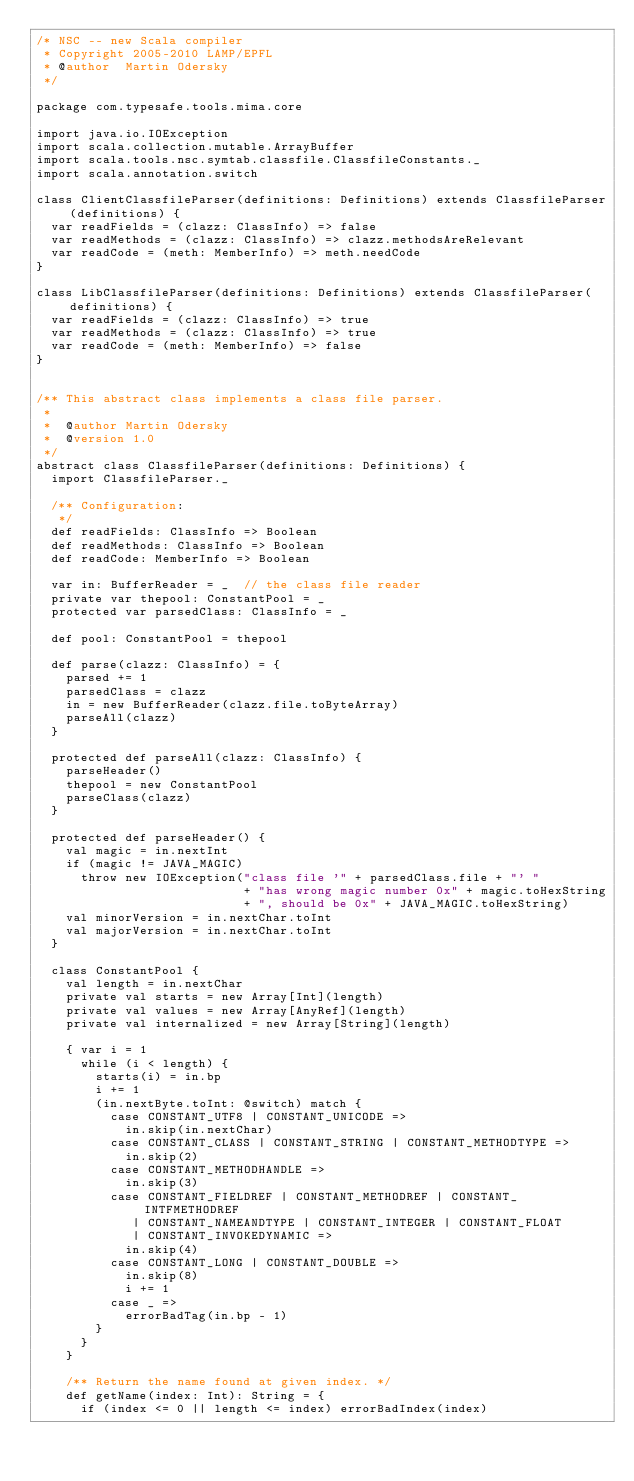<code> <loc_0><loc_0><loc_500><loc_500><_Scala_>/* NSC -- new Scala compiler
 * Copyright 2005-2010 LAMP/EPFL
 * @author  Martin Odersky
 */

package com.typesafe.tools.mima.core

import java.io.IOException
import scala.collection.mutable.ArrayBuffer
import scala.tools.nsc.symtab.classfile.ClassfileConstants._
import scala.annotation.switch

class ClientClassfileParser(definitions: Definitions) extends ClassfileParser(definitions) {
  var readFields = (clazz: ClassInfo) => false
  var readMethods = (clazz: ClassInfo) => clazz.methodsAreRelevant
  var readCode = (meth: MemberInfo) => meth.needCode
}

class LibClassfileParser(definitions: Definitions) extends ClassfileParser(definitions) {
  var readFields = (clazz: ClassInfo) => true
  var readMethods = (clazz: ClassInfo) => true
  var readCode = (meth: MemberInfo) => false
}


/** This abstract class implements a class file parser.
 *
 *  @author Martin Odersky
 *  @version 1.0
 */
abstract class ClassfileParser(definitions: Definitions) {
  import ClassfileParser._

  /** Configuration:
   */
  def readFields: ClassInfo => Boolean
  def readMethods: ClassInfo => Boolean
  def readCode: MemberInfo => Boolean

  var in: BufferReader = _  // the class file reader
  private var thepool: ConstantPool = _
  protected var parsedClass: ClassInfo = _

  def pool: ConstantPool = thepool

  def parse(clazz: ClassInfo) = {
    parsed += 1
    parsedClass = clazz
    in = new BufferReader(clazz.file.toByteArray)
    parseAll(clazz)
  }

  protected def parseAll(clazz: ClassInfo) {
    parseHeader()
    thepool = new ConstantPool
    parseClass(clazz)
  }

  protected def parseHeader() {
    val magic = in.nextInt
    if (magic != JAVA_MAGIC)
      throw new IOException("class file '" + parsedClass.file + "' "
                            + "has wrong magic number 0x" + magic.toHexString
                            + ", should be 0x" + JAVA_MAGIC.toHexString)
    val minorVersion = in.nextChar.toInt
    val majorVersion = in.nextChar.toInt
  }

  class ConstantPool {
    val length = in.nextChar
    private val starts = new Array[Int](length)
    private val values = new Array[AnyRef](length)
    private val internalized = new Array[String](length)

    { var i = 1
      while (i < length) {
        starts(i) = in.bp
        i += 1
        (in.nextByte.toInt: @switch) match {
          case CONSTANT_UTF8 | CONSTANT_UNICODE =>
            in.skip(in.nextChar)
          case CONSTANT_CLASS | CONSTANT_STRING | CONSTANT_METHODTYPE =>
            in.skip(2)
          case CONSTANT_METHODHANDLE =>
            in.skip(3)
          case CONSTANT_FIELDREF | CONSTANT_METHODREF | CONSTANT_INTFMETHODREF
             | CONSTANT_NAMEANDTYPE | CONSTANT_INTEGER | CONSTANT_FLOAT
             | CONSTANT_INVOKEDYNAMIC =>
            in.skip(4)
          case CONSTANT_LONG | CONSTANT_DOUBLE =>
            in.skip(8)
            i += 1
          case _ =>
            errorBadTag(in.bp - 1)
        }
      }
    }

    /** Return the name found at given index. */
    def getName(index: Int): String = {
      if (index <= 0 || length <= index) errorBadIndex(index)</code> 